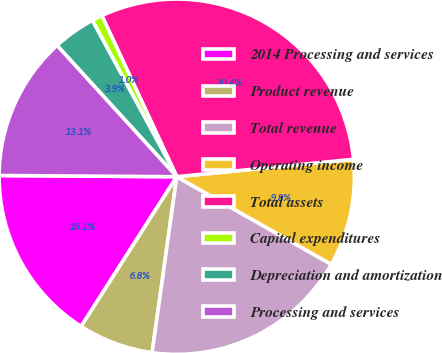Convert chart. <chart><loc_0><loc_0><loc_500><loc_500><pie_chart><fcel>2014 Processing and services<fcel>Product revenue<fcel>Total revenue<fcel>Operating income<fcel>Total assets<fcel>Capital expenditures<fcel>Depreciation and amortization<fcel>Processing and services<nl><fcel>16.06%<fcel>6.83%<fcel>19.0%<fcel>9.77%<fcel>30.36%<fcel>0.95%<fcel>3.89%<fcel>13.12%<nl></chart> 